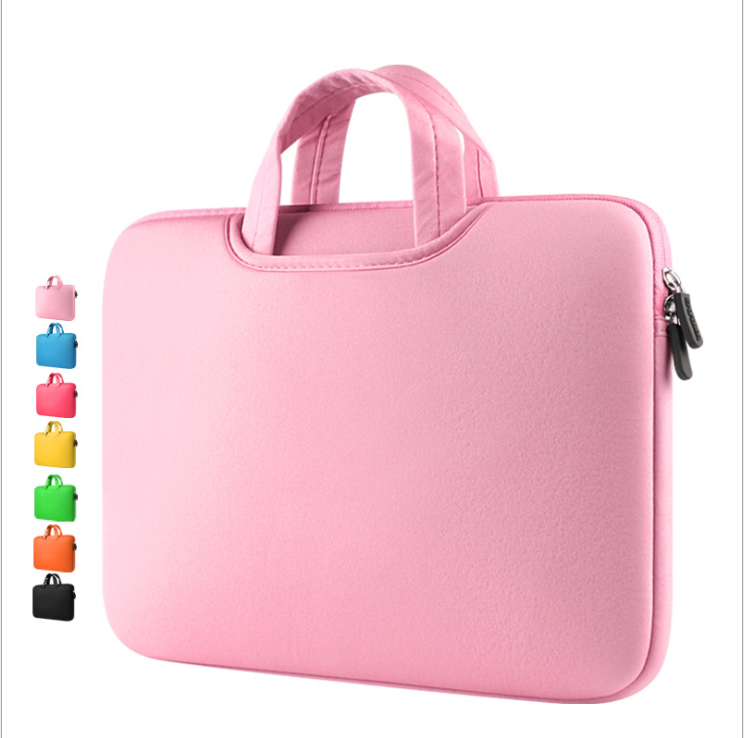What color options are available for this laptop sleeve, and how might different colors appeal to different consumer preferences? The laptop sleeve shown in the image is pink, but the displayed color variety includes blue, yellow, green, red, and black. Different colors can cater to personal style preferences or even organizational needs, allowing consumers to choose shades that reflect their personality or coordinate with other accessories. Bold colors like red or yellow might appeal to those looking to make a fashion statement, while more subdued tones like black or blue could be preferred in professional settings. 